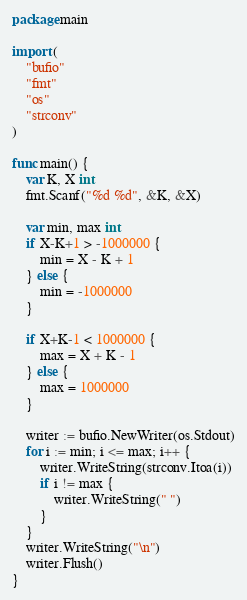<code> <loc_0><loc_0><loc_500><loc_500><_Go_>package main

import (
	"bufio"
	"fmt"
	"os"
	"strconv"
)

func main() {
	var K, X int
	fmt.Scanf("%d %d", &K, &X)

	var min, max int
	if X-K+1 > -1000000 {
		min = X - K + 1
	} else {
		min = -1000000
	}

	if X+K-1 < 1000000 {
		max = X + K - 1
	} else {
		max = 1000000
	}

	writer := bufio.NewWriter(os.Stdout)
	for i := min; i <= max; i++ {
		writer.WriteString(strconv.Itoa(i))
		if i != max {
			writer.WriteString(" ")
		}
	}
	writer.WriteString("\n")
	writer.Flush()
}
</code> 